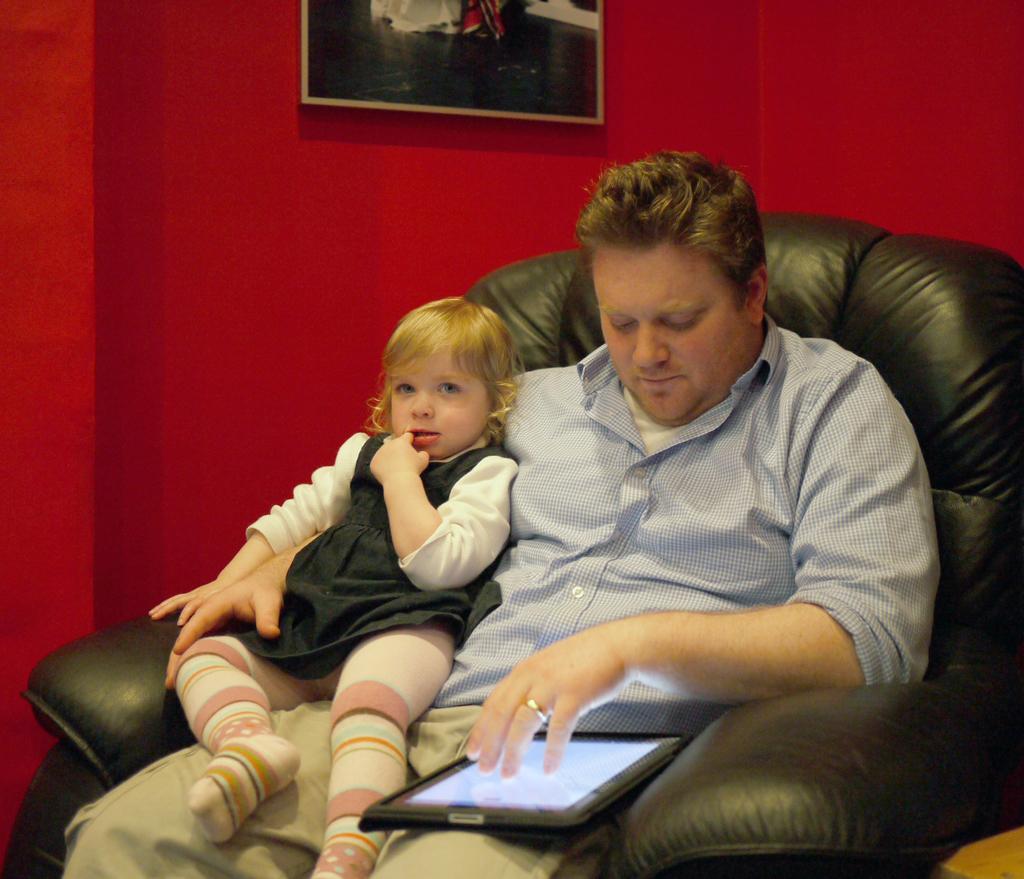Can you describe this image briefly? In the center of the image we can see a person and a kid sitting on a chair with tablet. In the background there is a wall and photo frame. 